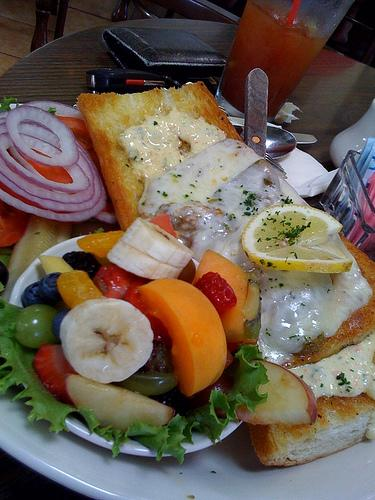What color are the onions on the top left part of the white plate?

Choices:
A) sweet
B) yellow
C) white
D) purple purple 